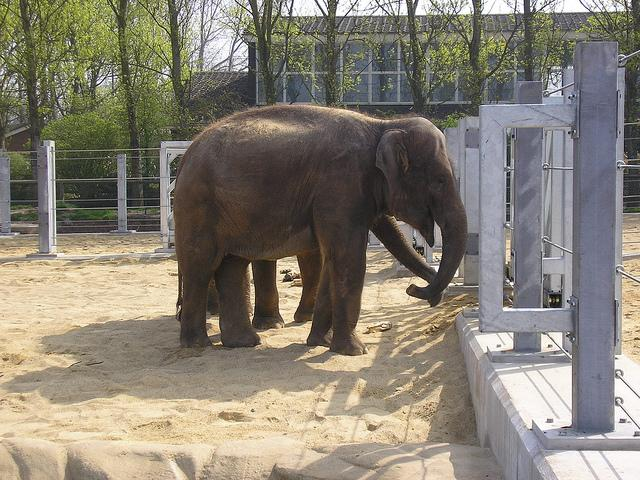What are the elephants standing in? Please explain your reasoning. sand. The elephants are near an area standing in sand. 